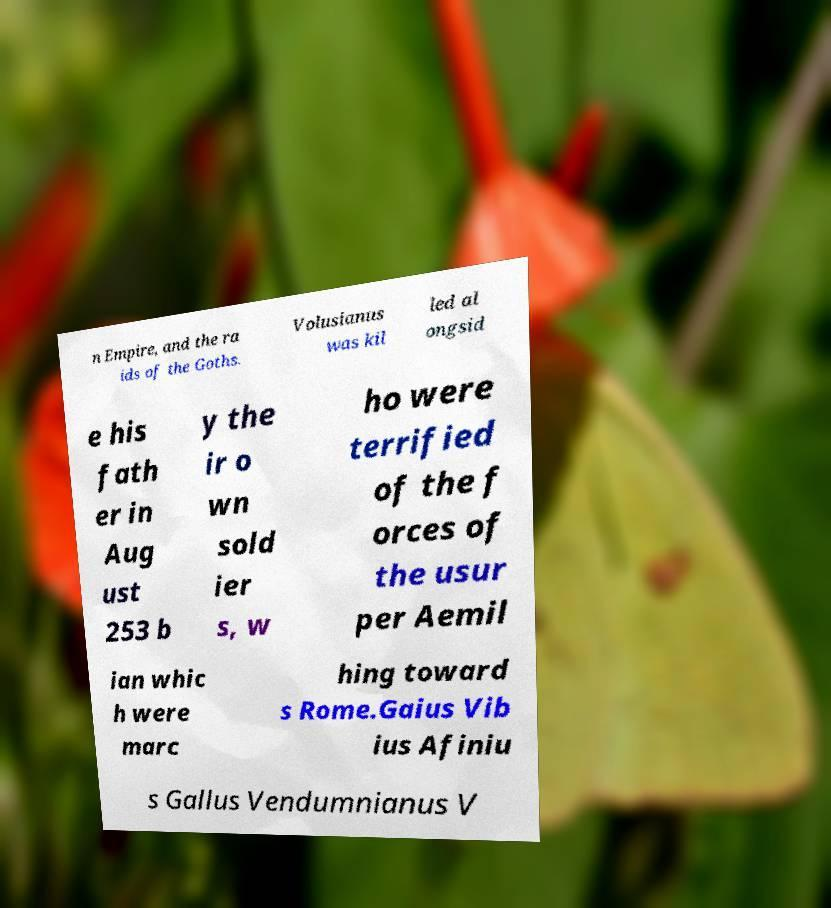Can you accurately transcribe the text from the provided image for me? n Empire, and the ra ids of the Goths. Volusianus was kil led al ongsid e his fath er in Aug ust 253 b y the ir o wn sold ier s, w ho were terrified of the f orces of the usur per Aemil ian whic h were marc hing toward s Rome.Gaius Vib ius Afiniu s Gallus Vendumnianus V 